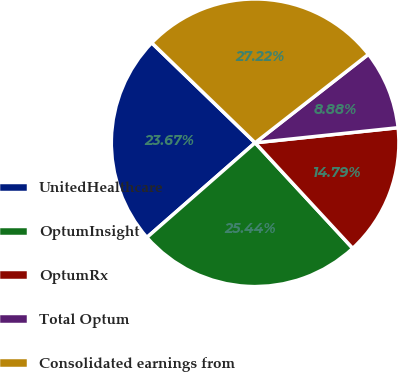<chart> <loc_0><loc_0><loc_500><loc_500><pie_chart><fcel>UnitedHealthcare<fcel>OptumInsight<fcel>OptumRx<fcel>Total Optum<fcel>Consolidated earnings from<nl><fcel>23.67%<fcel>25.44%<fcel>14.79%<fcel>8.88%<fcel>27.22%<nl></chart> 